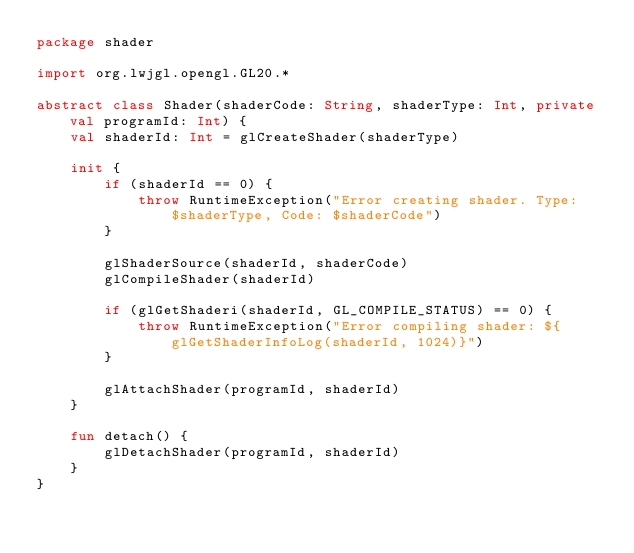<code> <loc_0><loc_0><loc_500><loc_500><_Kotlin_>package shader

import org.lwjgl.opengl.GL20.*

abstract class Shader(shaderCode: String, shaderType: Int, private val programId: Int) {
    val shaderId: Int = glCreateShader(shaderType)

    init {
        if (shaderId == 0) {
            throw RuntimeException("Error creating shader. Type: $shaderType, Code: $shaderCode")
        }

        glShaderSource(shaderId, shaderCode)
        glCompileShader(shaderId)

        if (glGetShaderi(shaderId, GL_COMPILE_STATUS) == 0) {
            throw RuntimeException("Error compiling shader: ${glGetShaderInfoLog(shaderId, 1024)}")
        }

        glAttachShader(programId, shaderId)
    }

    fun detach() {
        glDetachShader(programId, shaderId)
    }
}</code> 